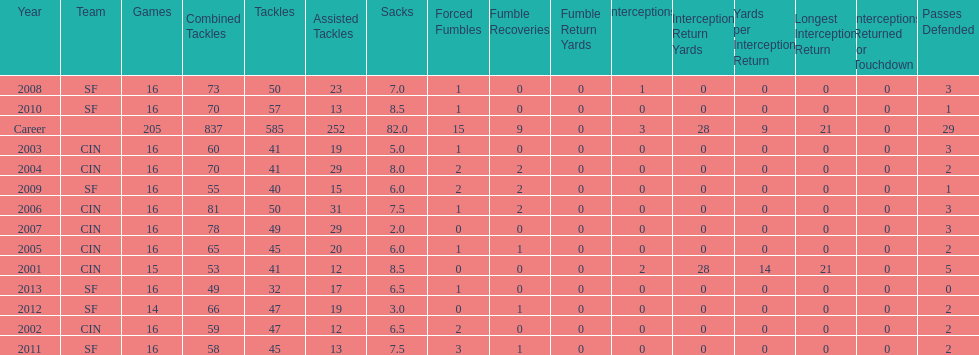How many sacks did this player have in his first five seasons? 34. 